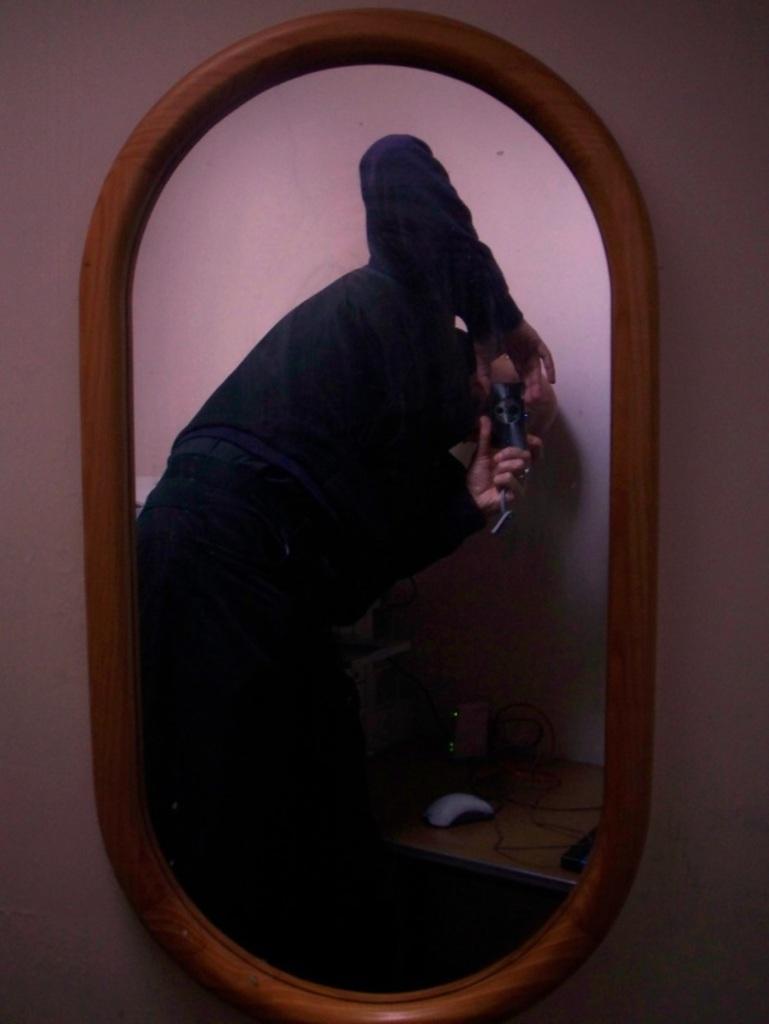In one or two sentences, can you explain what this image depicts? In this image there is a wall for that wall there is a mirror, in that mirror there is a reflection of a man holding camera in his hand and a table, on that table there are few objects. 